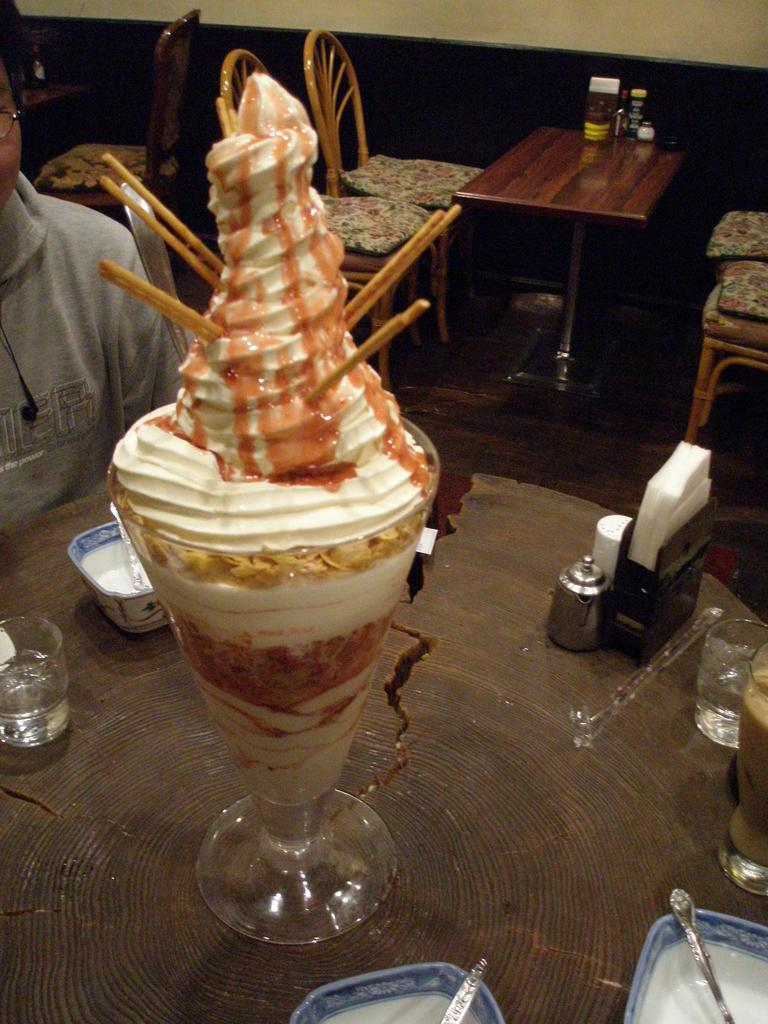What is inside the glass that is visible in the image? There is a glass full of ice cream in the image. How many glasses can be seen in the image? There are other glasses in the image. What other types of containers are present in the image? There are cups in the image. Can you describe the person in the image? There is a person in the image. What can be seen in the background of the image? There are tables and chairs in the background of the image. What type of rice is being served to the person in the image? There is no rice present in the image; it features a glass full of ice cream and other containers. Who is the manager of the establishment in the image? There is no indication of an establishment or a manager in the image. 